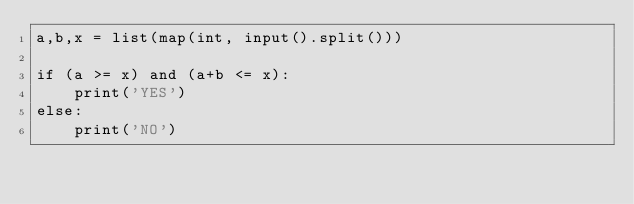<code> <loc_0><loc_0><loc_500><loc_500><_Python_>a,b,x = list(map(int, input().split()))

if (a >= x) and (a+b <= x):
    print('YES')
else:
    print('NO')</code> 